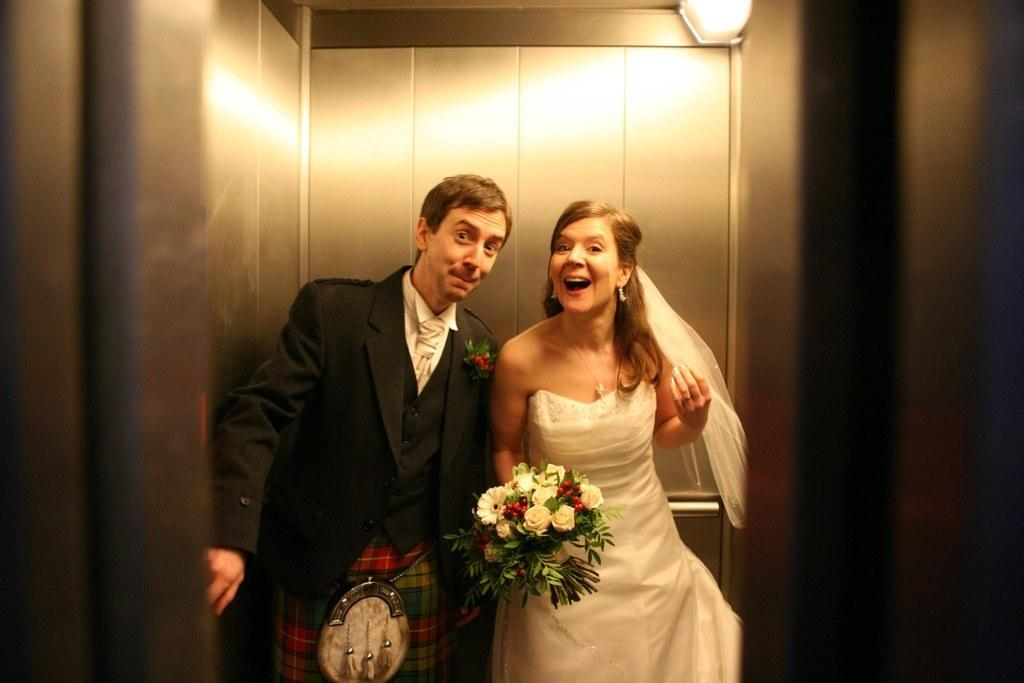What is the man doing in the image? The man is standing in the image. What is the woman holding in the image? The woman is holding a bouquet in the image. What is the woman's position in the image? The woman is also standing in the image. What can be seen in the background of the image? Walls and an unspecified object are visible in the background of the image. What type of rainstorm is depicted in the image? There is no rainstorm present in the image. What store is the man shopping at in the image? There is no store present in the image; it is an outdoor scene with a man standing and a woman holding a bouquet. 